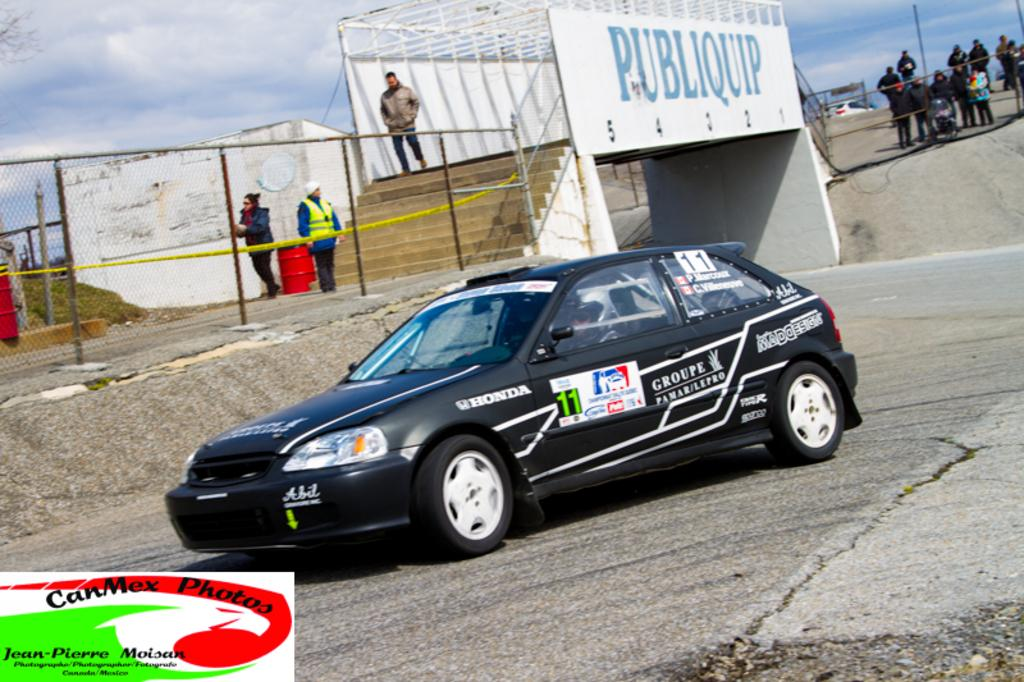What is the main subject in the middle of the image? There is a black car in the middle of the image. What is the man in the image doing? A man is walking in the image. What structure can be seen in the image? There is a bridge in the image. Where are the people located in the image? The people are standing on the right side of the image. What direction are the people looking in the image? The people are looking towards the left side of the image. What type of hat is the man wearing in the image? There is no hat visible on the man in the image. What is the man's opinion about the things he sees in the image? The image does not provide any information about the man's opinion, as it only shows his actions and not his thoughts or feelings. 